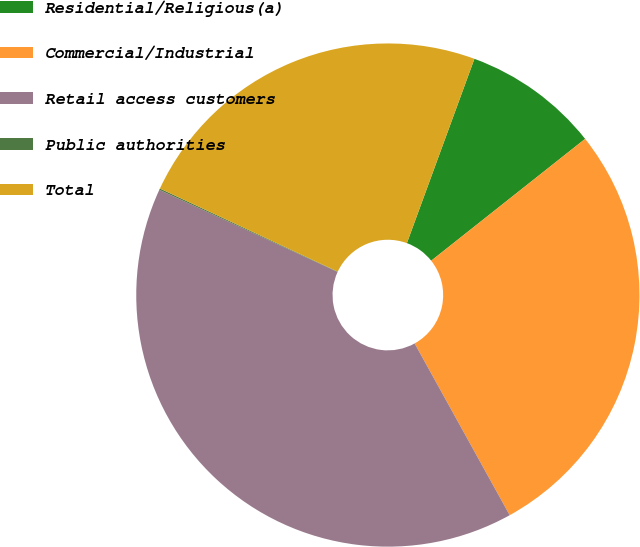<chart> <loc_0><loc_0><loc_500><loc_500><pie_chart><fcel>Residential/Religious(a)<fcel>Commercial/Industrial<fcel>Retail access customers<fcel>Public authorities<fcel>Total<nl><fcel>8.75%<fcel>27.61%<fcel>39.91%<fcel>0.09%<fcel>23.63%<nl></chart> 